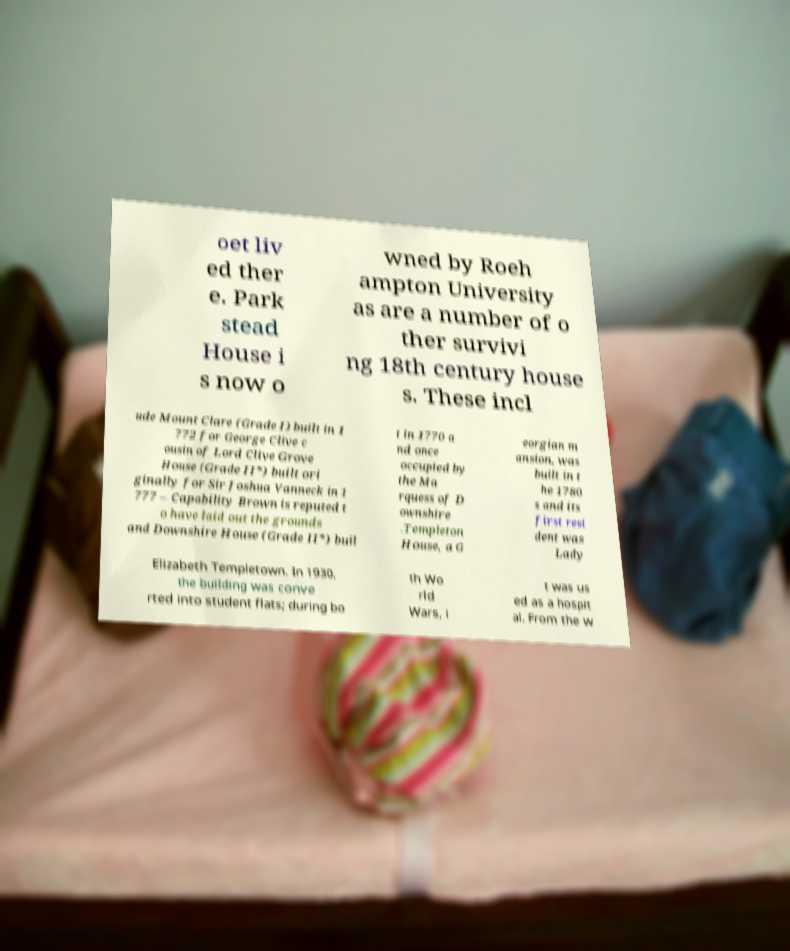Could you assist in decoding the text presented in this image and type it out clearly? oet liv ed ther e. Park stead House i s now o wned by Roeh ampton University as are a number of o ther survivi ng 18th century house s. These incl ude Mount Clare (Grade I) built in 1 772 for George Clive c ousin of Lord Clive Grove House (Grade II*) built ori ginally for Sir Joshua Vanneck in 1 777 – Capability Brown is reputed t o have laid out the grounds and Downshire House (Grade II*) buil t in 1770 a nd once occupied by the Ma rquess of D ownshire .Templeton House, a G eorgian m ansion, was built in t he 1780 s and its first resi dent was Lady Elizabeth Templetown. In 1930, the building was conve rted into student flats; during bo th Wo rld Wars, i t was us ed as a hospit al. From the w 